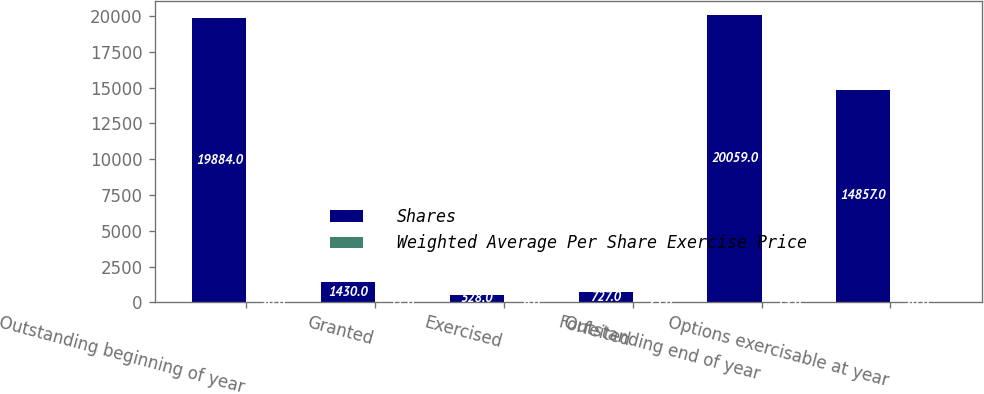Convert chart to OTSL. <chart><loc_0><loc_0><loc_500><loc_500><stacked_bar_chart><ecel><fcel>Outstanding beginning of year<fcel>Granted<fcel>Exercised<fcel>Forfeited<fcel>Outstanding end of year<fcel>Options exercisable at year<nl><fcel>Shares<fcel>19884<fcel>1430<fcel>528<fcel>727<fcel>20059<fcel>14857<nl><fcel>Weighted Average Per Share Exercise Price<fcel>20<fcel>11<fcel>8<fcel>23<fcel>19<fcel>20<nl></chart> 